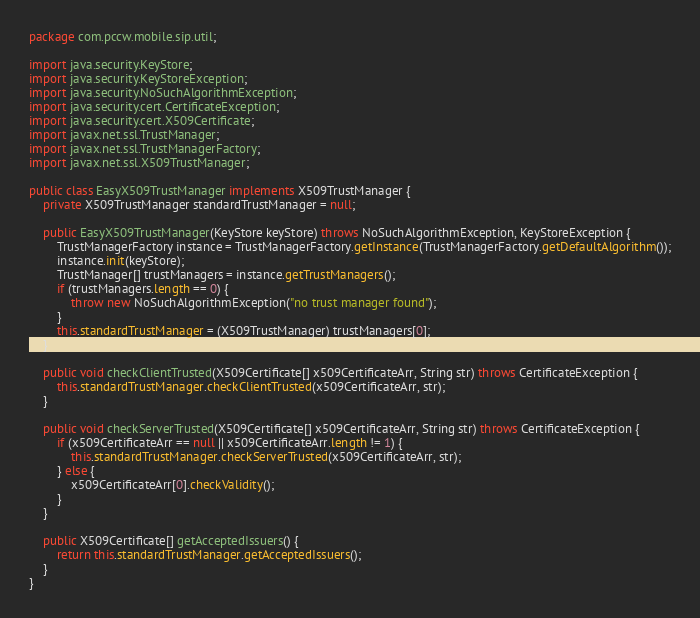Convert code to text. <code><loc_0><loc_0><loc_500><loc_500><_Java_>package com.pccw.mobile.sip.util;

import java.security.KeyStore;
import java.security.KeyStoreException;
import java.security.NoSuchAlgorithmException;
import java.security.cert.CertificateException;
import java.security.cert.X509Certificate;
import javax.net.ssl.TrustManager;
import javax.net.ssl.TrustManagerFactory;
import javax.net.ssl.X509TrustManager;

public class EasyX509TrustManager implements X509TrustManager {
    private X509TrustManager standardTrustManager = null;

    public EasyX509TrustManager(KeyStore keyStore) throws NoSuchAlgorithmException, KeyStoreException {
        TrustManagerFactory instance = TrustManagerFactory.getInstance(TrustManagerFactory.getDefaultAlgorithm());
        instance.init(keyStore);
        TrustManager[] trustManagers = instance.getTrustManagers();
        if (trustManagers.length == 0) {
            throw new NoSuchAlgorithmException("no trust manager found");
        }
        this.standardTrustManager = (X509TrustManager) trustManagers[0];
    }

    public void checkClientTrusted(X509Certificate[] x509CertificateArr, String str) throws CertificateException {
        this.standardTrustManager.checkClientTrusted(x509CertificateArr, str);
    }

    public void checkServerTrusted(X509Certificate[] x509CertificateArr, String str) throws CertificateException {
        if (x509CertificateArr == null || x509CertificateArr.length != 1) {
            this.standardTrustManager.checkServerTrusted(x509CertificateArr, str);
        } else {
            x509CertificateArr[0].checkValidity();
        }
    }

    public X509Certificate[] getAcceptedIssuers() {
        return this.standardTrustManager.getAcceptedIssuers();
    }
}
</code> 